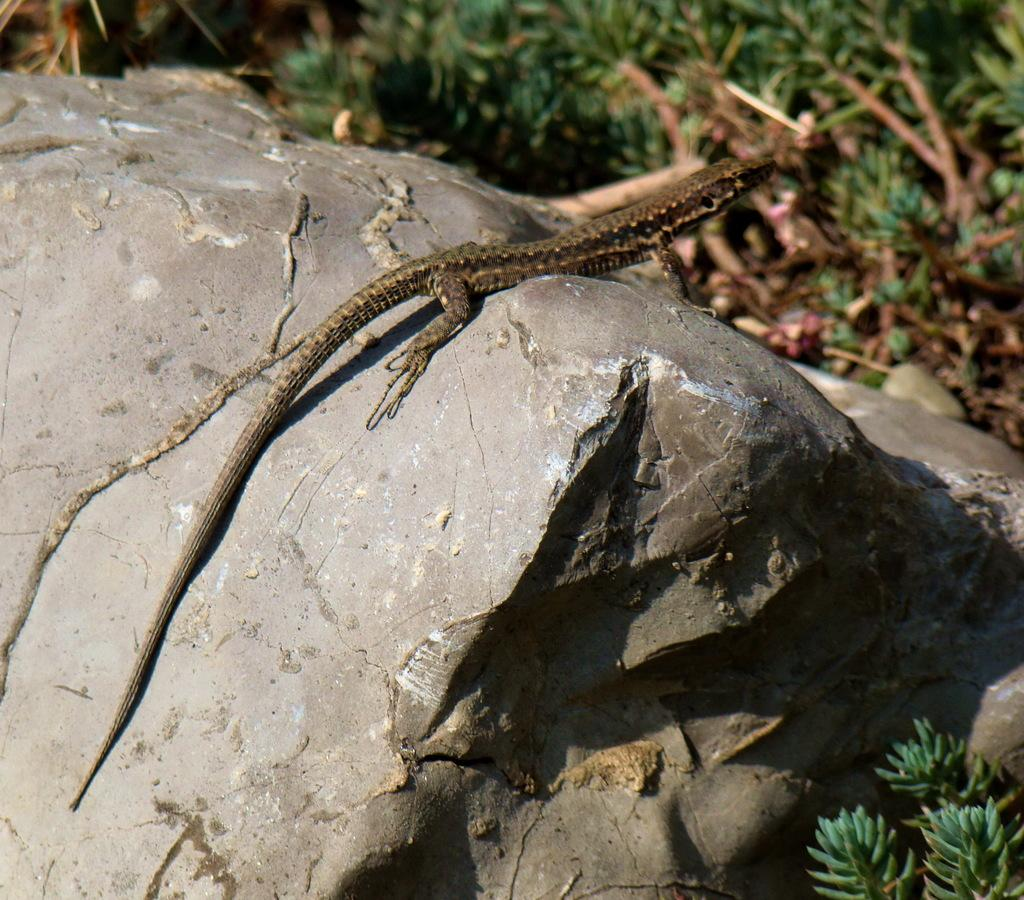What type of animal is in the image? There is a reptile in the image. Where is the reptile located? The reptile is on a rock. What type of beginner lesson is being taught in the image? There is no indication of a beginner lesson or any teaching activity in the image; it features a reptile on a rock. 